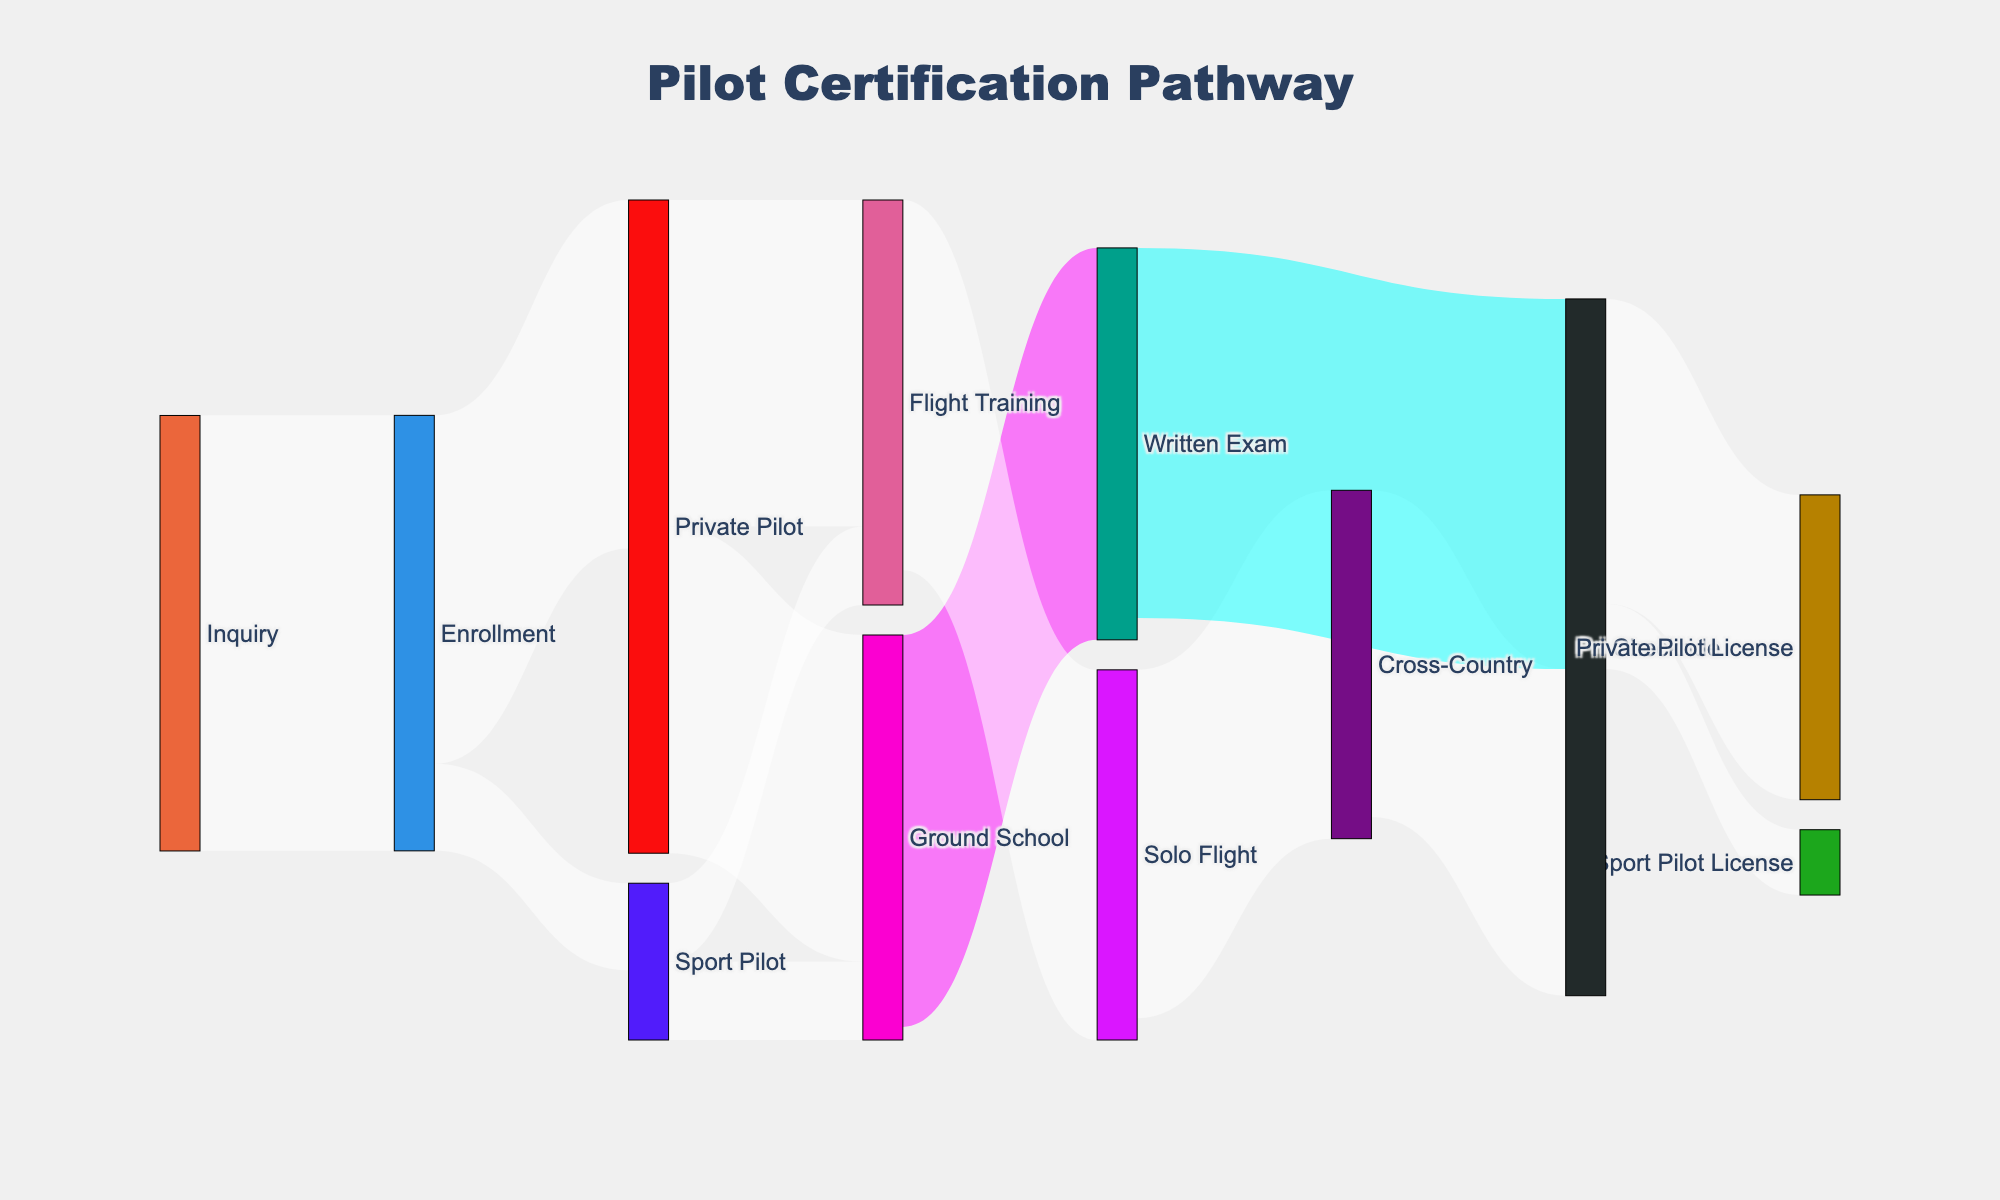Which step has the highest number of participants? The number of participants can be identified by looking at the widest flows between each node. The step with the highest number is from 'Inquiry' to 'Enrollment' with 100 participants.
Answer: Inquiry to Enrollment How many participants move from Private Pilot to Flight Training? The diagram shows a flow from 'Private Pilot' to 'Flight Training'. The number corresponding to this is 75.
Answer: 75 What percentage of enrolled participants go on to achieve a Private Pilot License? First, note that 80 participants from 'Enrollment' move to 'Private Pilot'. From 'Checkride', 70 achieve a 'Private Pilot License'. Therefore, the percentage is (70/100) * 100%.
Answer: 70% How many participants pass the Written Exam? Observe the flow from 'Ground School' to 'Written Exam' which indicates 90 out of those who attended Ground School pass the Written Exam.
Answer: 90 What is the total number of participants who reach the Ground School step? Add the number of participants from 'Private Pilot' and 'Sport Pilot' to 'Ground School'. It's 75 (Private Pilot) + 18 (Sport Pilot).
Answer: 93 Which step has a higher dropout rate: from 'Inquiry' to 'Enrollment' or from 'Enrollment' to 'Private Pilot'? Examine the differences: 'Inquiry' to 'Enrollment' has 100 participants. 'Enrollment' to 'Private Pilot' has 80 participants, so 20 drop out here. The dropout from 'Inquiry' to 'Enrollment' is 0 since it's the starting point. Hence, the step 'Enrollment' to 'Private Pilot' has a higher dropout.
Answer: Enrollment to Private Pilot How does the number of participants who achieve the Private Pilot License compare to those who achieve the Sport Pilot License? Compare the values at the final steps. 'Private Pilot License' is achieved by 70 participants and 'Sport Pilot License' by 15.
Answer: More achieve Private Pilot License What is the success rate from Solo Flight to Checkride? Observe the flow from 'Solo Flight' (80) to 'Checkride' which is via 'Cross-Country'. The number reaching 'Checkride from Solo Flight is indicated by the 75 participants crossing the 'Checkride' step. (75/80)*100%
Answer: 93.75% If someone reaches the Checkride, what is the likelihood they achieve either type of pilot license? Add the numbers who achieve 'Private Pilot License' (70) and 'Sport Pilot License' (15) and divide by the total reaching 'Checkride' (75 + 15 = 90). The likelihood is then (85/90) * 100%.
Answer: 94.44% 